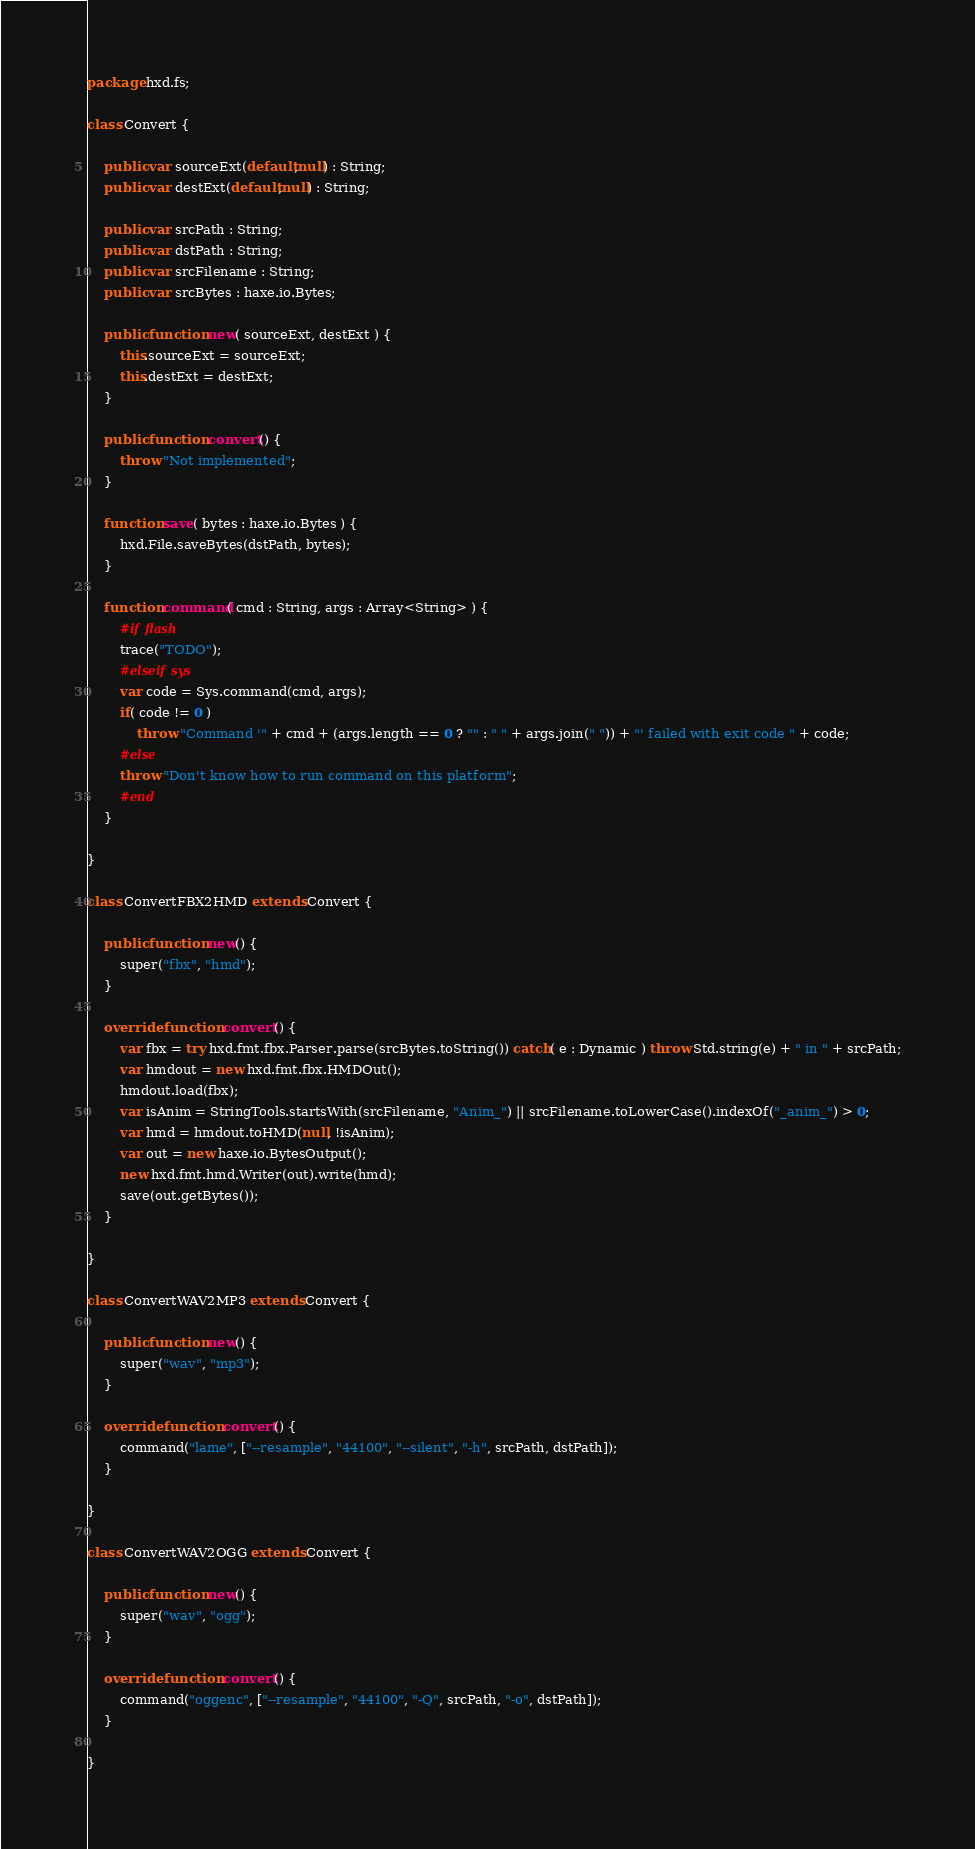<code> <loc_0><loc_0><loc_500><loc_500><_Haxe_>package hxd.fs;

class Convert {

	public var sourceExt(default,null) : String;
	public var destExt(default,null) : String;

	public var srcPath : String;
	public var dstPath : String;
	public var srcFilename : String;
	public var srcBytes : haxe.io.Bytes;

	public function new( sourceExt, destExt ) {
		this.sourceExt = sourceExt;
		this.destExt = destExt;
	}

	public function convert() {
		throw "Not implemented";
	}

	function save( bytes : haxe.io.Bytes ) {
		hxd.File.saveBytes(dstPath, bytes);
	}

	function command( cmd : String, args : Array<String> ) {
		#if flash
		trace("TODO");
		#elseif sys
		var code = Sys.command(cmd, args);
		if( code != 0 )
			throw "Command '" + cmd + (args.length == 0 ? "" : " " + args.join(" ")) + "' failed with exit code " + code;
		#else
		throw "Don't know how to run command on this platform";
		#end
	}

}

class ConvertFBX2HMD extends Convert {

	public function new() {
		super("fbx", "hmd");
	}

	override function convert() {
		var fbx = try hxd.fmt.fbx.Parser.parse(srcBytes.toString()) catch( e : Dynamic ) throw Std.string(e) + " in " + srcPath;
		var hmdout = new hxd.fmt.fbx.HMDOut();
		hmdout.load(fbx);
		var isAnim = StringTools.startsWith(srcFilename, "Anim_") || srcFilename.toLowerCase().indexOf("_anim_") > 0;
		var hmd = hmdout.toHMD(null, !isAnim);
		var out = new haxe.io.BytesOutput();
		new hxd.fmt.hmd.Writer(out).write(hmd);
		save(out.getBytes());
	}

}

class ConvertWAV2MP3 extends Convert {

	public function new() {
		super("wav", "mp3");
	}

	override function convert() {
		command("lame", ["--resample", "44100", "--silent", "-h", srcPath, dstPath]);
	}

}

class ConvertWAV2OGG extends Convert {

	public function new() {
		super("wav", "ogg");
	}

	override function convert() {
		command("oggenc", ["--resample", "44100", "-Q", srcPath, "-o", dstPath]);
	}

}</code> 